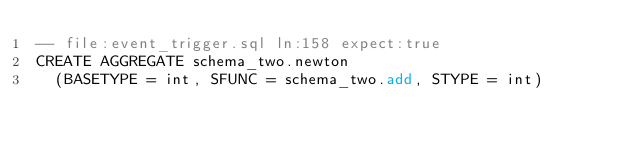Convert code to text. <code><loc_0><loc_0><loc_500><loc_500><_SQL_>-- file:event_trigger.sql ln:158 expect:true
CREATE AGGREGATE schema_two.newton
  (BASETYPE = int, SFUNC = schema_two.add, STYPE = int)
</code> 